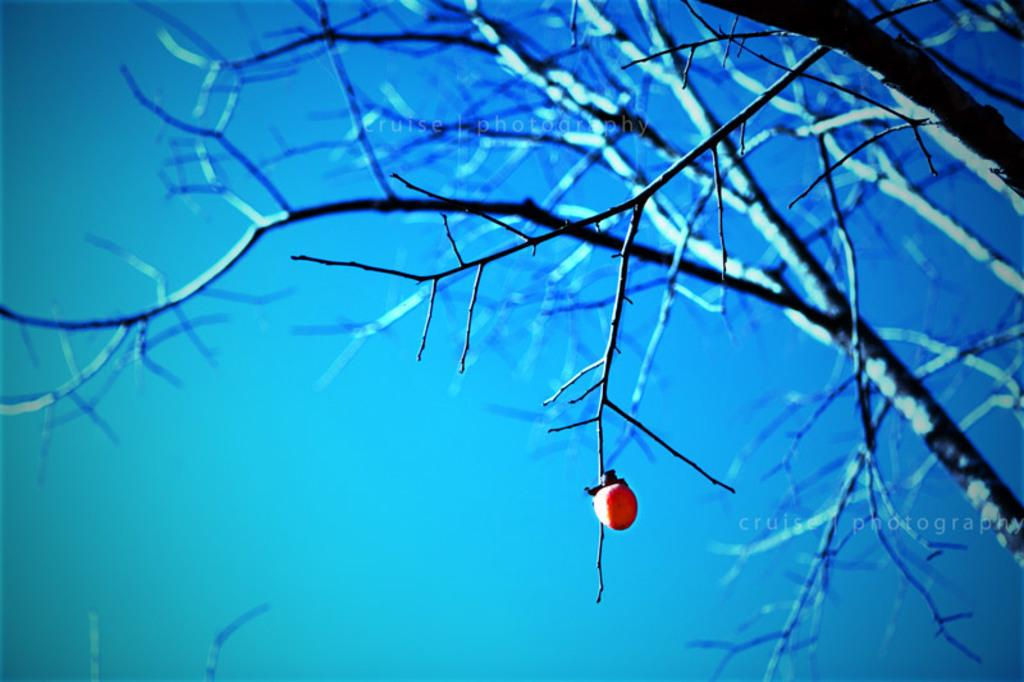What is on the branch of the tree in the image? There is a fruit on the branch of a tree in the image. What can be seen in the background of the image? The sky is visible in the background of the image. What type of pan is being used to cook the fruit in the image? There is no pan or cooking activity present in the image; it simply shows a fruit on a tree branch with the sky visible in the background. 